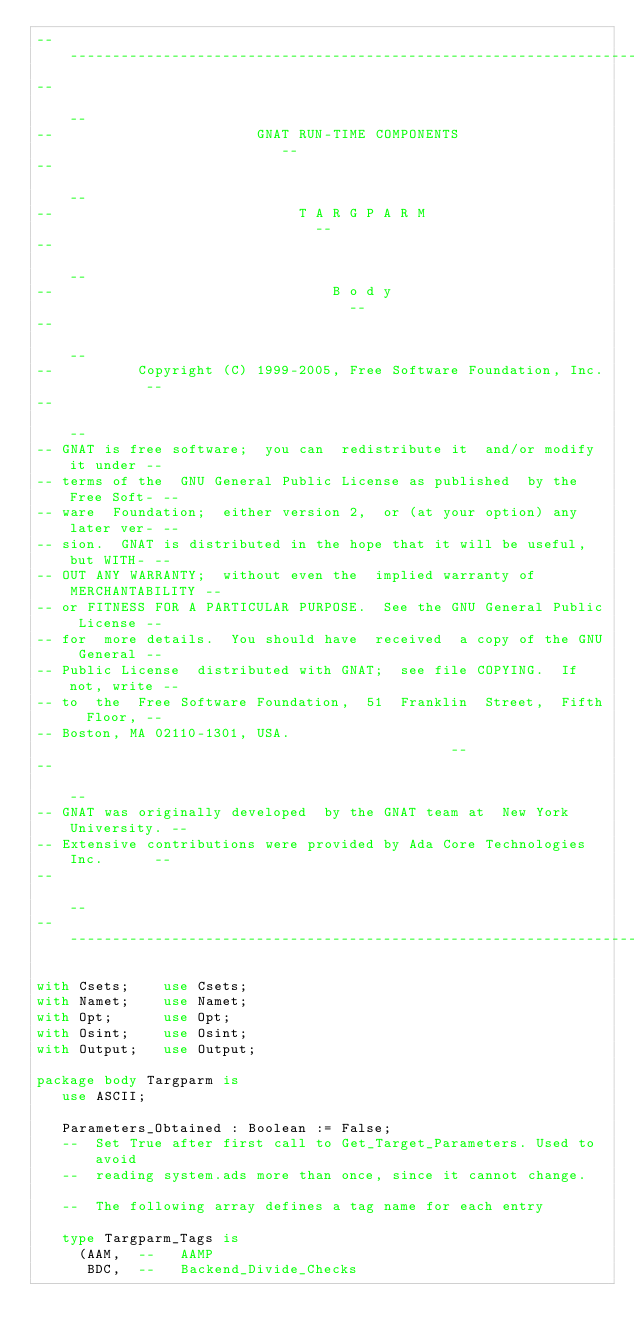<code> <loc_0><loc_0><loc_500><loc_500><_Ada_>------------------------------------------------------------------------------
--                                                                          --
--                        GNAT RUN-TIME COMPONENTS                          --
--                                                                          --
--                             T A R G P A R M                              --
--                                                                          --
--                                 B o d y                                  --
--                                                                          --
--          Copyright (C) 1999-2005, Free Software Foundation, Inc.         --
--                                                                          --
-- GNAT is free software;  you can  redistribute it  and/or modify it under --
-- terms of the  GNU General Public License as published  by the Free Soft- --
-- ware  Foundation;  either version 2,  or (at your option) any later ver- --
-- sion.  GNAT is distributed in the hope that it will be useful, but WITH- --
-- OUT ANY WARRANTY;  without even the  implied warranty of MERCHANTABILITY --
-- or FITNESS FOR A PARTICULAR PURPOSE.  See the GNU General Public License --
-- for  more details.  You should have  received  a copy of the GNU General --
-- Public License  distributed with GNAT;  see file COPYING.  If not, write --
-- to  the  Free Software Foundation,  51  Franklin  Street,  Fifth  Floor, --
-- Boston, MA 02110-1301, USA.                                              --
--                                                                          --
-- GNAT was originally developed  by the GNAT team at  New York University. --
-- Extensive contributions were provided by Ada Core Technologies Inc.      --
--                                                                          --
------------------------------------------------------------------------------

with Csets;    use Csets;
with Namet;    use Namet;
with Opt;      use Opt;
with Osint;    use Osint;
with Output;   use Output;

package body Targparm is
   use ASCII;

   Parameters_Obtained : Boolean := False;
   --  Set True after first call to Get_Target_Parameters. Used to avoid
   --  reading system.ads more than once, since it cannot change.

   --  The following array defines a tag name for each entry

   type Targparm_Tags is
     (AAM,  --   AAMP
      BDC,  --   Backend_Divide_Checks</code> 